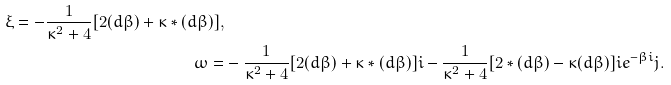Convert formula to latex. <formula><loc_0><loc_0><loc_500><loc_500>\xi = - \frac { 1 } { \kappa ^ { 2 } + 4 } [ 2 ( d \beta ) + \kappa \ast ( d \beta ) ] , \\ \omega = & - \frac { 1 } { \kappa ^ { 2 } + 4 } [ 2 ( d \beta ) + \kappa \ast ( d \beta ) ] i - \frac { 1 } { \kappa ^ { 2 } + 4 } [ 2 \ast ( d \beta ) - \kappa ( d \beta ) ] i e ^ { - \beta i } j .</formula> 